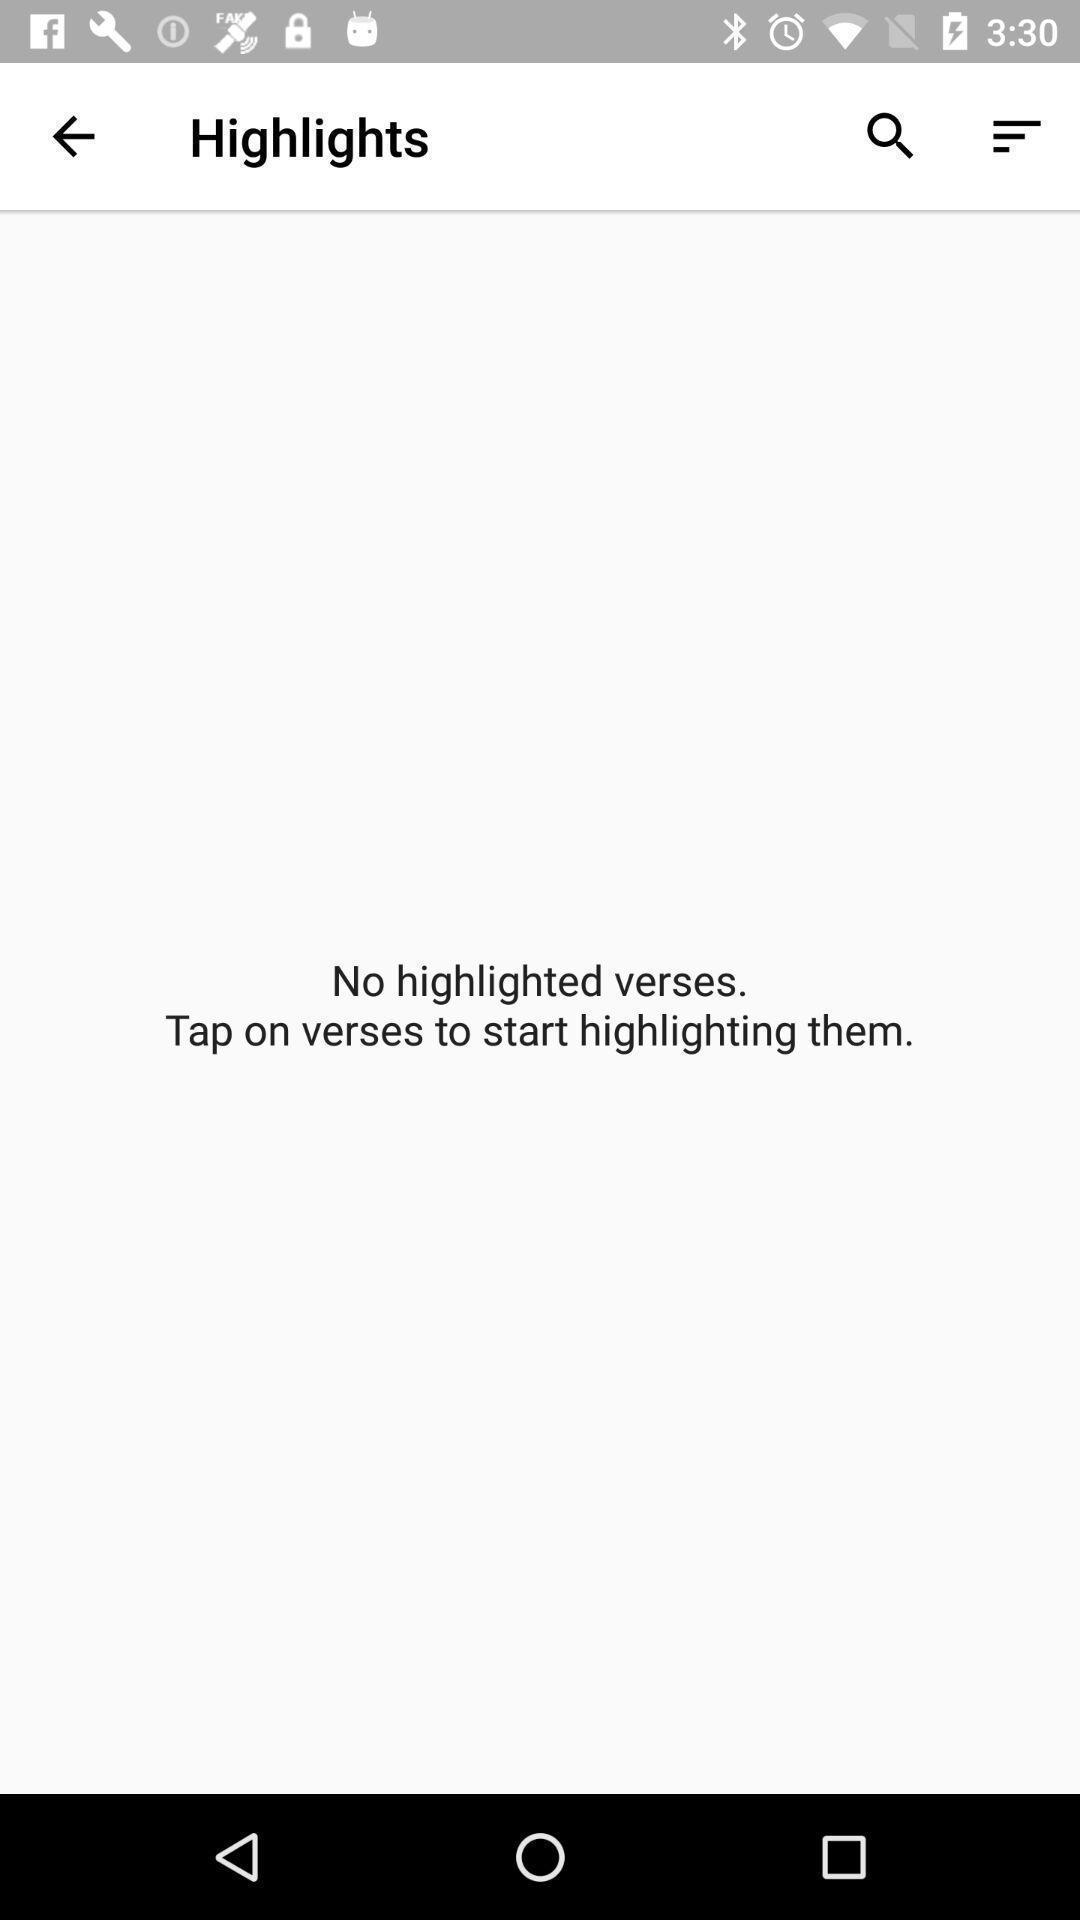What is the overall content of this screenshot? Screen displaying highlighted results and a search icon. 